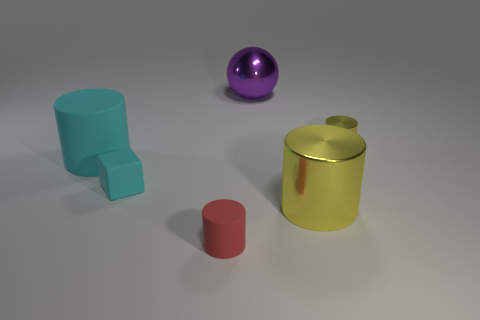Subtract 1 cylinders. How many cylinders are left? 3 Add 1 small yellow rubber cylinders. How many objects exist? 7 Subtract all blocks. How many objects are left? 5 Subtract all tiny shiny things. Subtract all big metal balls. How many objects are left? 4 Add 6 purple objects. How many purple objects are left? 7 Add 3 small objects. How many small objects exist? 6 Subtract 0 green spheres. How many objects are left? 6 